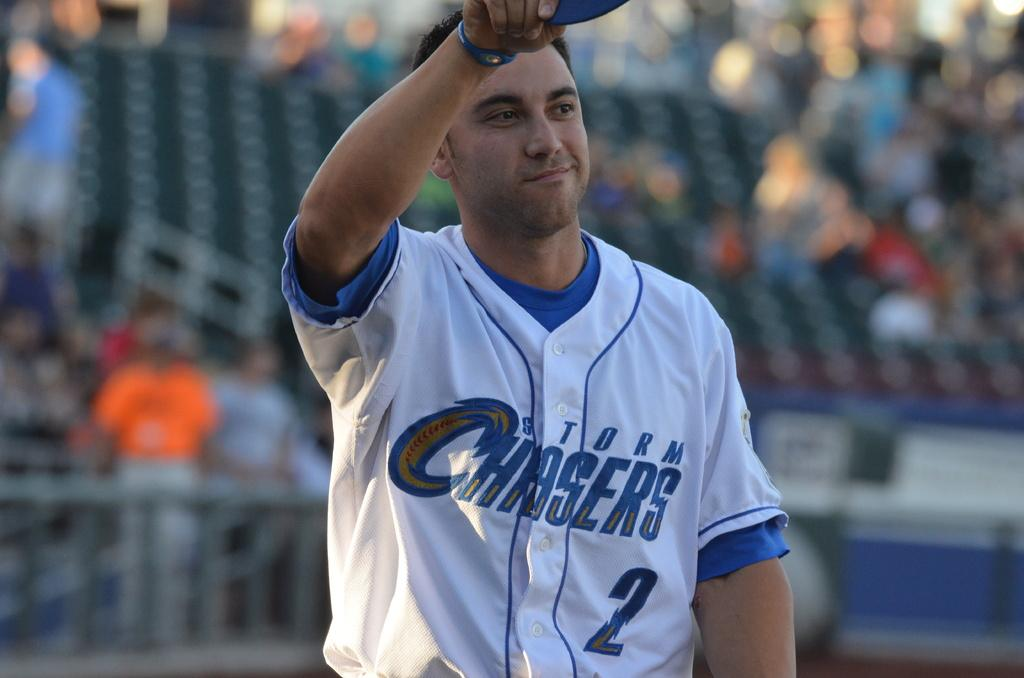<image>
Provide a brief description of the given image. storm chasers player number 2 waving and half empty stands behind him 